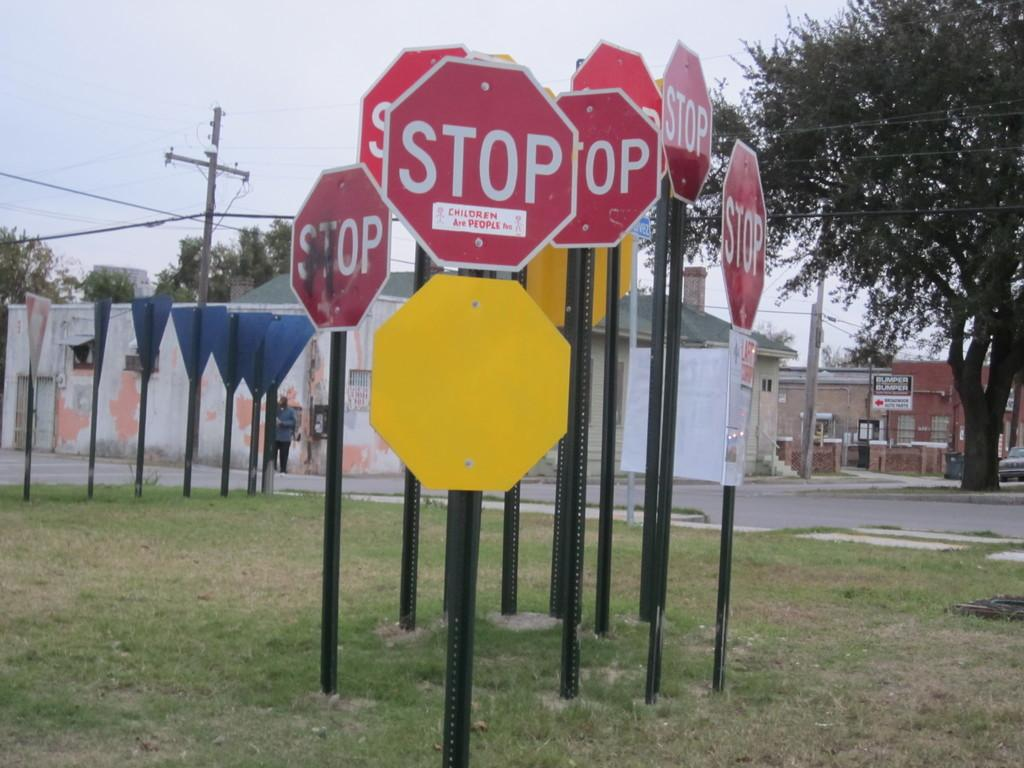<image>
Offer a succinct explanation of the picture presented. A cluster of signs in a patch of grass and they all say Stop. 